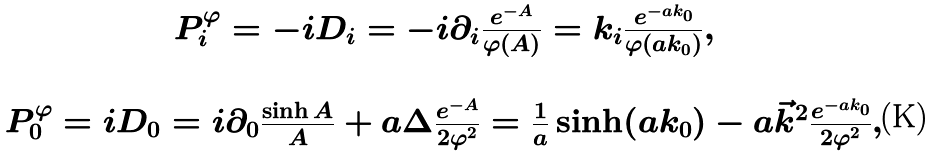<formula> <loc_0><loc_0><loc_500><loc_500>\begin{array} { c } P _ { i } ^ { \varphi } = - i D _ { i } = - i \partial _ { i } \frac { e ^ { - A } } { \varphi ( A ) } = k _ { i } \frac { e ^ { - a k _ { 0 } } } { \varphi ( a k _ { 0 } ) } , \\ \\ P _ { 0 } ^ { \varphi } = i D _ { 0 } = i \partial _ { 0 } \frac { \sinh A } { A } + a \Delta \frac { e ^ { - A } } { 2 \varphi ^ { 2 } } = \frac { 1 } { a } \sinh ( a k _ { 0 } ) - a { \vec { k } } ^ { 2 } \frac { e ^ { - a k _ { 0 } } } { 2 \varphi ^ { 2 } } , \end{array}</formula> 